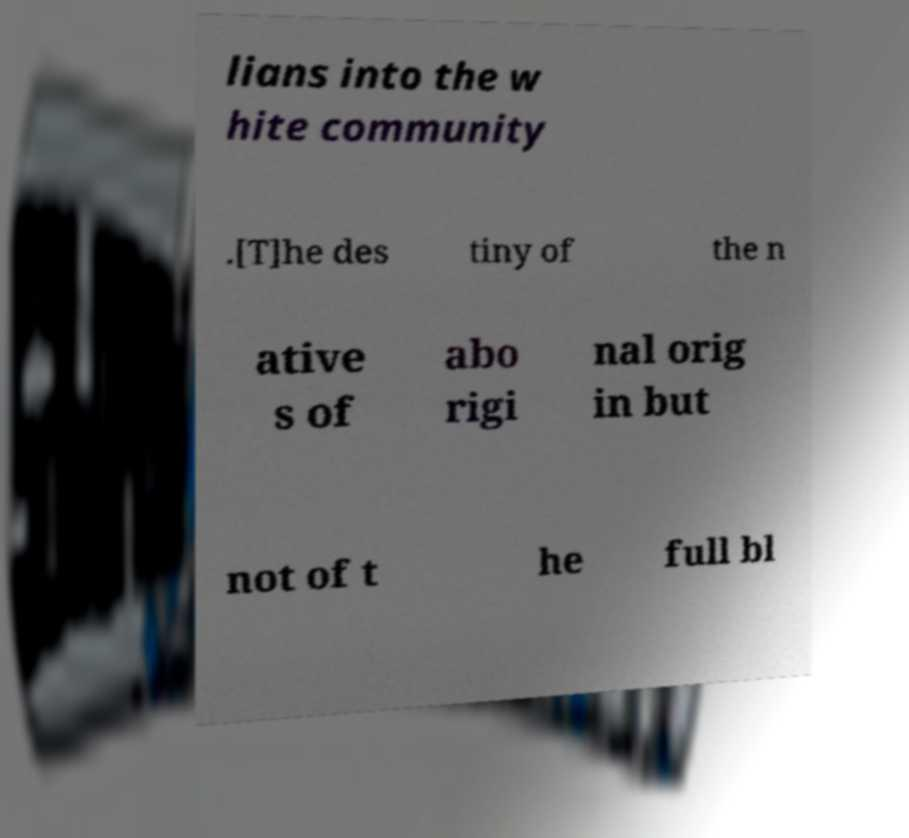Could you assist in decoding the text presented in this image and type it out clearly? lians into the w hite community .[T]he des tiny of the n ative s of abo rigi nal orig in but not of t he full bl 